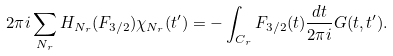<formula> <loc_0><loc_0><loc_500><loc_500>2 \pi i \sum _ { N _ { r } } H _ { N _ { r } } ( F _ { 3 / 2 } ) \chi _ { N _ { r } } ( t ^ { \prime } ) = - \int _ { C _ { r } } F _ { 3 / 2 } ( t ) \frac { d t } { 2 \pi i } G ( t , t ^ { \prime } ) .</formula> 